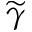<formula> <loc_0><loc_0><loc_500><loc_500>\widetilde { \gamma }</formula> 